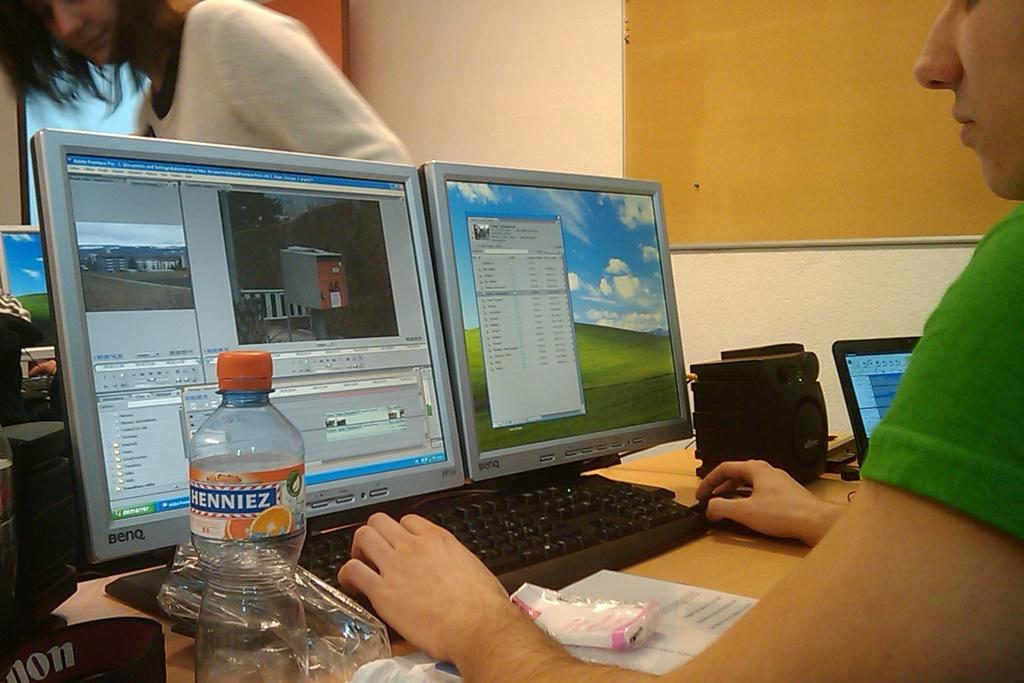Provide a one-sentence caption for the provided image. A clear bottle with an orange bottle cap labeled Henniez. 